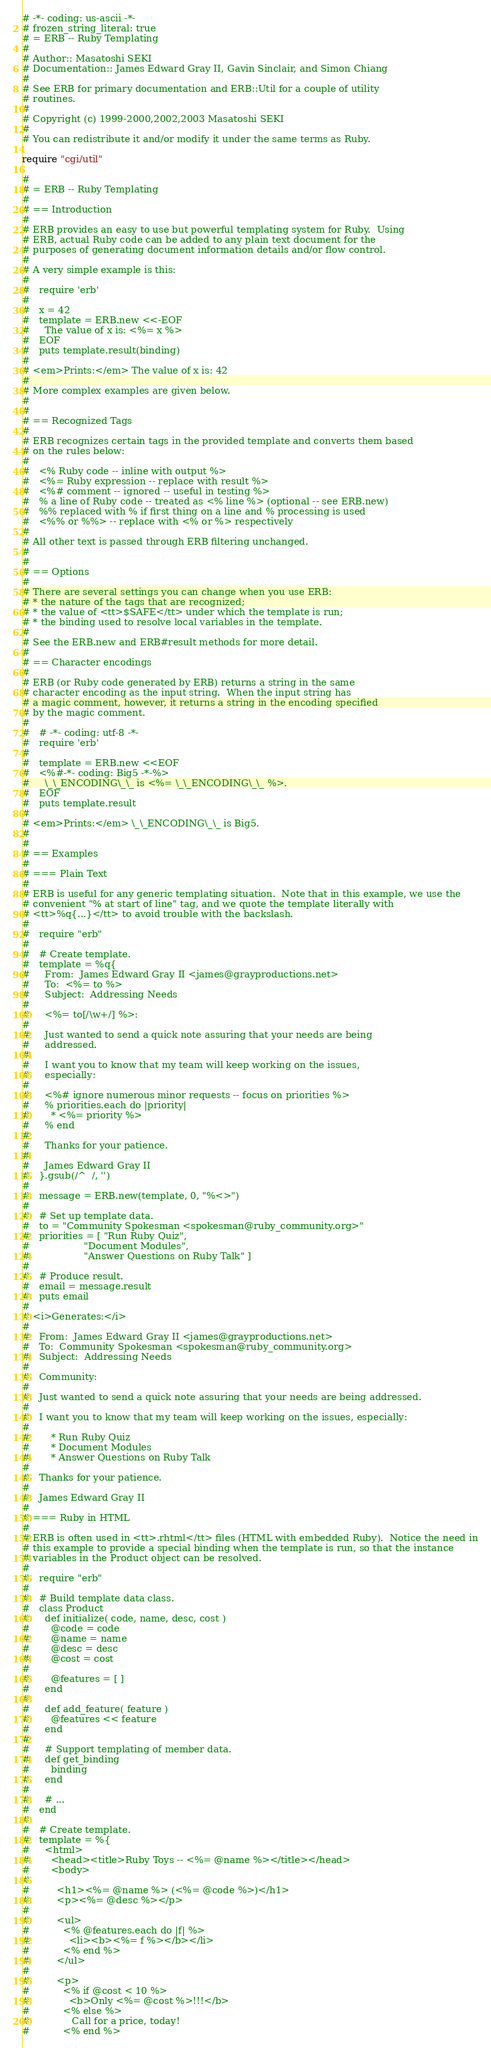Convert code to text. <code><loc_0><loc_0><loc_500><loc_500><_Ruby_># -*- coding: us-ascii -*-
# frozen_string_literal: true
# = ERB -- Ruby Templating
#
# Author:: Masatoshi SEKI
# Documentation:: James Edward Gray II, Gavin Sinclair, and Simon Chiang
#
# See ERB for primary documentation and ERB::Util for a couple of utility
# routines.
#
# Copyright (c) 1999-2000,2002,2003 Masatoshi SEKI
#
# You can redistribute it and/or modify it under the same terms as Ruby.

require "cgi/util"

#
# = ERB -- Ruby Templating
#
# == Introduction
#
# ERB provides an easy to use but powerful templating system for Ruby.  Using
# ERB, actual Ruby code can be added to any plain text document for the
# purposes of generating document information details and/or flow control.
#
# A very simple example is this:
#
#   require 'erb'
#
#   x = 42
#   template = ERB.new <<-EOF
#     The value of x is: <%= x %>
#   EOF
#   puts template.result(binding)
#
# <em>Prints:</em> The value of x is: 42
#
# More complex examples are given below.
#
#
# == Recognized Tags
#
# ERB recognizes certain tags in the provided template and converts them based
# on the rules below:
#
#   <% Ruby code -- inline with output %>
#   <%= Ruby expression -- replace with result %>
#   <%# comment -- ignored -- useful in testing %>
#   % a line of Ruby code -- treated as <% line %> (optional -- see ERB.new)
#   %% replaced with % if first thing on a line and % processing is used
#   <%% or %%> -- replace with <% or %> respectively
#
# All other text is passed through ERB filtering unchanged.
#
#
# == Options
#
# There are several settings you can change when you use ERB:
# * the nature of the tags that are recognized;
# * the value of <tt>$SAFE</tt> under which the template is run;
# * the binding used to resolve local variables in the template.
#
# See the ERB.new and ERB#result methods for more detail.
#
# == Character encodings
#
# ERB (or Ruby code generated by ERB) returns a string in the same
# character encoding as the input string.  When the input string has
# a magic comment, however, it returns a string in the encoding specified
# by the magic comment.
#
#   # -*- coding: utf-8 -*-
#   require 'erb'
#
#   template = ERB.new <<EOF
#   <%#-*- coding: Big5 -*-%>
#     \_\_ENCODING\_\_ is <%= \_\_ENCODING\_\_ %>.
#   EOF
#   puts template.result
#
# <em>Prints:</em> \_\_ENCODING\_\_ is Big5.
#
#
# == Examples
#
# === Plain Text
#
# ERB is useful for any generic templating situation.  Note that in this example, we use the
# convenient "% at start of line" tag, and we quote the template literally with
# <tt>%q{...}</tt> to avoid trouble with the backslash.
#
#   require "erb"
#
#   # Create template.
#   template = %q{
#     From:  James Edward Gray II <james@grayproductions.net>
#     To:  <%= to %>
#     Subject:  Addressing Needs
#
#     <%= to[/\w+/] %>:
#
#     Just wanted to send a quick note assuring that your needs are being
#     addressed.
#
#     I want you to know that my team will keep working on the issues,
#     especially:
#
#     <%# ignore numerous minor requests -- focus on priorities %>
#     % priorities.each do |priority|
#       * <%= priority %>
#     % end
#
#     Thanks for your patience.
#
#     James Edward Gray II
#   }.gsub(/^  /, '')
#
#   message = ERB.new(template, 0, "%<>")
#
#   # Set up template data.
#   to = "Community Spokesman <spokesman@ruby_community.org>"
#   priorities = [ "Run Ruby Quiz",
#                  "Document Modules",
#                  "Answer Questions on Ruby Talk" ]
#
#   # Produce result.
#   email = message.result
#   puts email
#
# <i>Generates:</i>
#
#   From:  James Edward Gray II <james@grayproductions.net>
#   To:  Community Spokesman <spokesman@ruby_community.org>
#   Subject:  Addressing Needs
#
#   Community:
#
#   Just wanted to send a quick note assuring that your needs are being addressed.
#
#   I want you to know that my team will keep working on the issues, especially:
#
#       * Run Ruby Quiz
#       * Document Modules
#       * Answer Questions on Ruby Talk
#
#   Thanks for your patience.
#
#   James Edward Gray II
#
# === Ruby in HTML
#
# ERB is often used in <tt>.rhtml</tt> files (HTML with embedded Ruby).  Notice the need in
# this example to provide a special binding when the template is run, so that the instance
# variables in the Product object can be resolved.
#
#   require "erb"
#
#   # Build template data class.
#   class Product
#     def initialize( code, name, desc, cost )
#       @code = code
#       @name = name
#       @desc = desc
#       @cost = cost
#
#       @features = [ ]
#     end
#
#     def add_feature( feature )
#       @features << feature
#     end
#
#     # Support templating of member data.
#     def get_binding
#       binding
#     end
#
#     # ...
#   end
#
#   # Create template.
#   template = %{
#     <html>
#       <head><title>Ruby Toys -- <%= @name %></title></head>
#       <body>
#
#         <h1><%= @name %> (<%= @code %>)</h1>
#         <p><%= @desc %></p>
#
#         <ul>
#           <% @features.each do |f| %>
#             <li><b><%= f %></b></li>
#           <% end %>
#         </ul>
#
#         <p>
#           <% if @cost < 10 %>
#             <b>Only <%= @cost %>!!!</b>
#           <% else %>
#              Call for a price, today!
#           <% end %></code> 